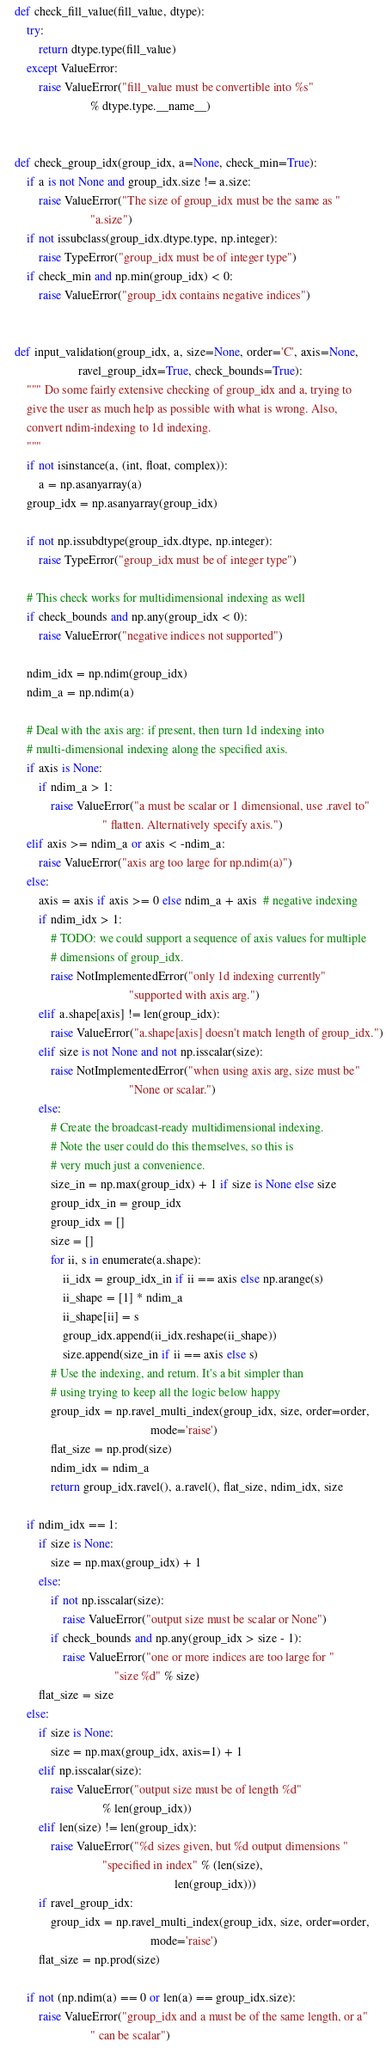<code> <loc_0><loc_0><loc_500><loc_500><_Python_>

    def check_fill_value(fill_value, dtype):
        try:
            return dtype.type(fill_value)
        except ValueError:
            raise ValueError("fill_value must be convertible into %s"
                             % dtype.type.__name__)


    def check_group_idx(group_idx, a=None, check_min=True):
        if a is not None and group_idx.size != a.size:
            raise ValueError("The size of group_idx must be the same as "
                             "a.size")
        if not issubclass(group_idx.dtype.type, np.integer):
            raise TypeError("group_idx must be of integer type")
        if check_min and np.min(group_idx) < 0:
            raise ValueError("group_idx contains negative indices")


    def input_validation(group_idx, a, size=None, order='C', axis=None,
                         ravel_group_idx=True, check_bounds=True):
        """ Do some fairly extensive checking of group_idx and a, trying to
        give the user as much help as possible with what is wrong. Also,
        convert ndim-indexing to 1d indexing.
        """
        if not isinstance(a, (int, float, complex)):
            a = np.asanyarray(a)
        group_idx = np.asanyarray(group_idx)

        if not np.issubdtype(group_idx.dtype, np.integer):
            raise TypeError("group_idx must be of integer type")

        # This check works for multidimensional indexing as well
        if check_bounds and np.any(group_idx < 0):
            raise ValueError("negative indices not supported")

        ndim_idx = np.ndim(group_idx)
        ndim_a = np.ndim(a)

        # Deal with the axis arg: if present, then turn 1d indexing into
        # multi-dimensional indexing along the specified axis.
        if axis is None:
            if ndim_a > 1:
                raise ValueError("a must be scalar or 1 dimensional, use .ravel to"
                                 " flatten. Alternatively specify axis.")
        elif axis >= ndim_a or axis < -ndim_a:
            raise ValueError("axis arg too large for np.ndim(a)")
        else:
            axis = axis if axis >= 0 else ndim_a + axis  # negative indexing
            if ndim_idx > 1:
                # TODO: we could support a sequence of axis values for multiple
                # dimensions of group_idx.
                raise NotImplementedError("only 1d indexing currently"
                                          "supported with axis arg.")
            elif a.shape[axis] != len(group_idx):
                raise ValueError("a.shape[axis] doesn't match length of group_idx.")
            elif size is not None and not np.isscalar(size):
                raise NotImplementedError("when using axis arg, size must be"
                                          "None or scalar.")
            else:
                # Create the broadcast-ready multidimensional indexing.
                # Note the user could do this themselves, so this is
                # very much just a convenience.
                size_in = np.max(group_idx) + 1 if size is None else size
                group_idx_in = group_idx
                group_idx = []
                size = []
                for ii, s in enumerate(a.shape):
                    ii_idx = group_idx_in if ii == axis else np.arange(s)
                    ii_shape = [1] * ndim_a
                    ii_shape[ii] = s
                    group_idx.append(ii_idx.reshape(ii_shape))
                    size.append(size_in if ii == axis else s)
                # Use the indexing, and return. It's a bit simpler than
                # using trying to keep all the logic below happy
                group_idx = np.ravel_multi_index(group_idx, size, order=order,
                                                 mode='raise')
                flat_size = np.prod(size)
                ndim_idx = ndim_a
                return group_idx.ravel(), a.ravel(), flat_size, ndim_idx, size

        if ndim_idx == 1:
            if size is None:
                size = np.max(group_idx) + 1
            else:
                if not np.isscalar(size):
                    raise ValueError("output size must be scalar or None")
                if check_bounds and np.any(group_idx > size - 1):
                    raise ValueError("one or more indices are too large for "
                                     "size %d" % size)
            flat_size = size
        else:
            if size is None:
                size = np.max(group_idx, axis=1) + 1
            elif np.isscalar(size):
                raise ValueError("output size must be of length %d"
                                 % len(group_idx))
            elif len(size) != len(group_idx):
                raise ValueError("%d sizes given, but %d output dimensions "
                                 "specified in index" % (len(size),
                                                         len(group_idx)))
            if ravel_group_idx:
                group_idx = np.ravel_multi_index(group_idx, size, order=order,
                                                 mode='raise')
            flat_size = np.prod(size)

        if not (np.ndim(a) == 0 or len(a) == group_idx.size):
            raise ValueError("group_idx and a must be of the same length, or a"
                             " can be scalar")
</code> 